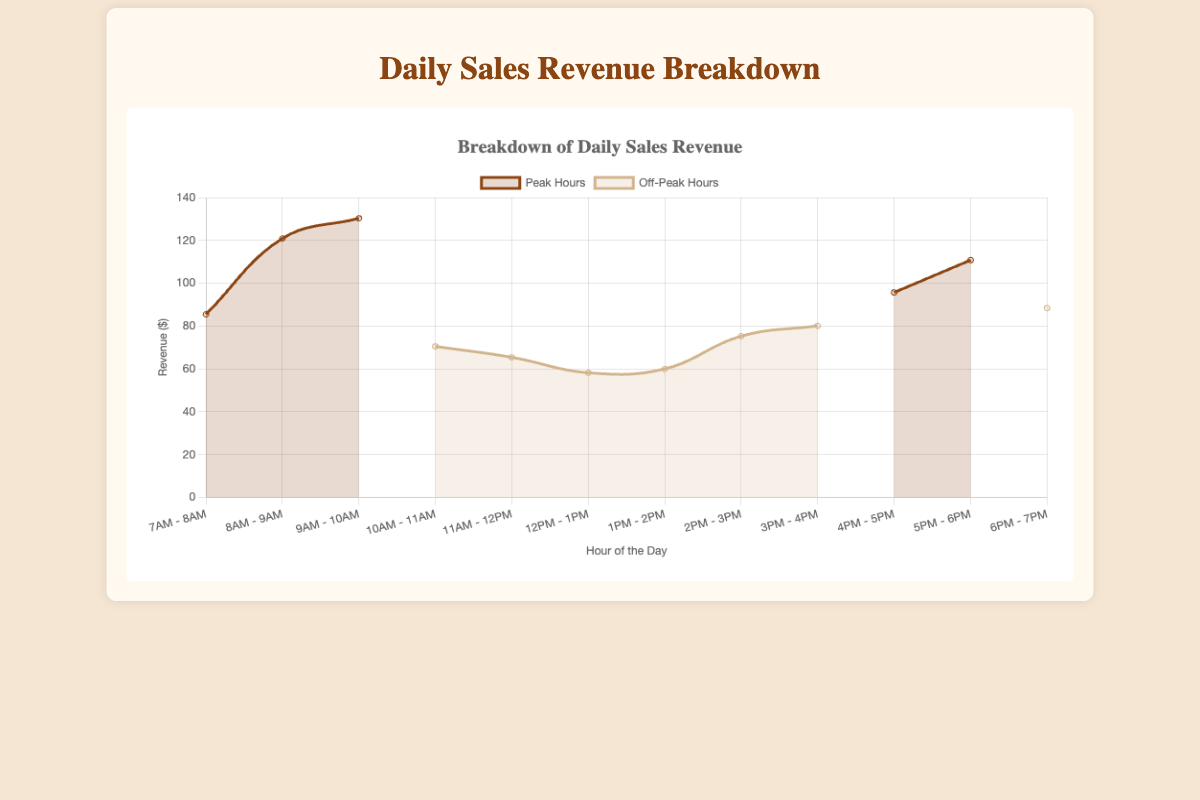What is the title of the chart? The title of the chart is displayed at the top and provides a summary of what the chart represents.
Answer: Daily Sales Revenue Breakdown What time period shows the highest revenue in peak hours? Look for the hour with the highest value amongst the data points marked as peak hours in the chart.
Answer: 9AM - 10AM Which hour has the lowest sales revenue in off-peak hours? Identify the lowest value among the data points marked as off-peak hours in the chart.
Answer: 12PM - 1PM How does the revenue from 8AM - 9AM compare to the revenue from 4PM - 5PM? Compare the revenue amounts for the two specified hours.
Answer: 8AM - 9AM has higher revenue What is the total revenue for off-peak hours? Add the revenue amounts for all hours marked as off-peak. Calculation: 70.5 + 65.4 + 58.2 + 60.0 + 75.3 + 80.1 + 88.4 = 498.9
Answer: 498.9 Average revenue during peak hours? Sum the revenues during peak hours and divide by the number of peak hour data points. Calculation: (85.5 + 120.9 + 130.3 + 95.7 + 110.8) / 5 = 108.64
Answer: 108.64 Which hour has higher revenue: 11AM - 12PM or 3PM - 4PM? Compare the revenues for the two specified hours.
Answer: 3PM - 4PM Identify the range of hours with consistent off-peak sales revenue? Look for consecutive hours where the revenue level is stable.
Answer: 10AM - 12PM What is the pattern of sales revenue throughout the day? Observe the rise and fall of revenue over the hours, noting any peaks and troughs.
Answer: Peaks in the morning and late afternoon, dips during midday How many peaks are observed in the chart? Count the distinct high points in the chart where the revenue significantly increases.
Answer: Two peaks 